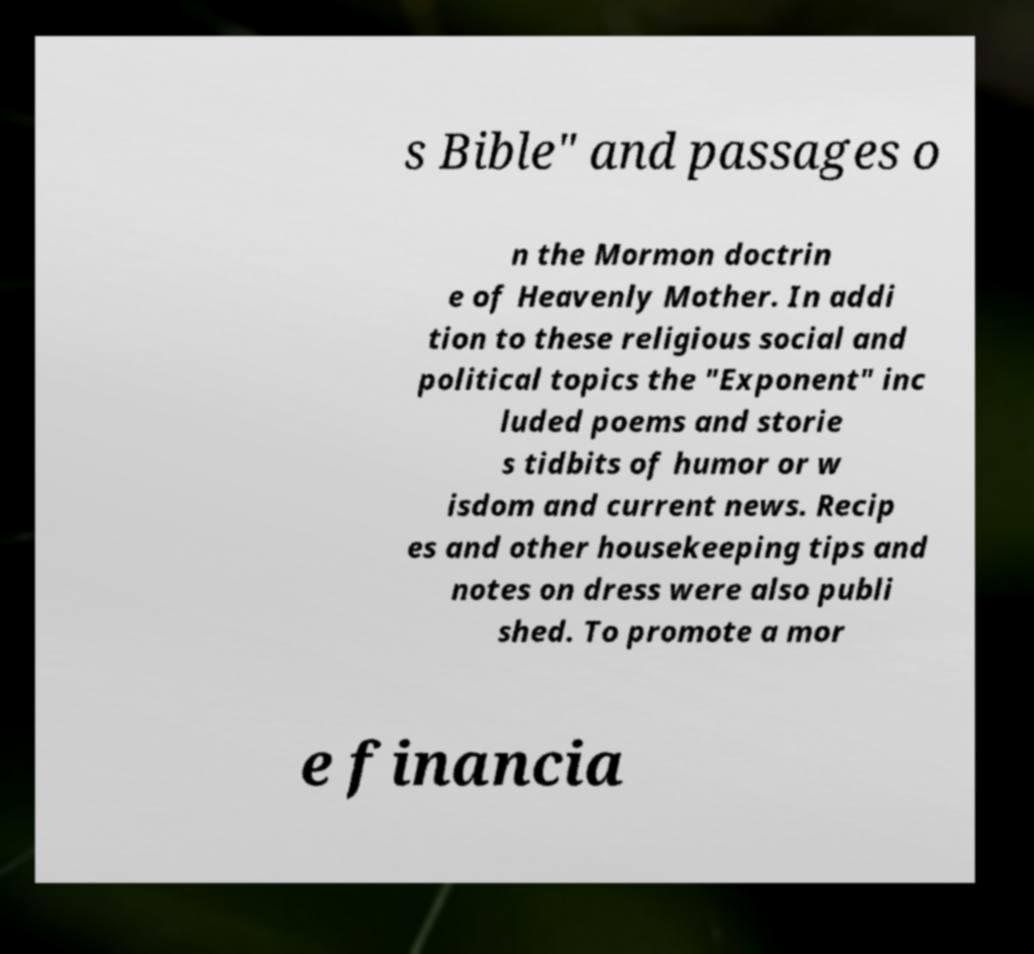Could you extract and type out the text from this image? s Bible" and passages o n the Mormon doctrin e of Heavenly Mother. In addi tion to these religious social and political topics the "Exponent" inc luded poems and storie s tidbits of humor or w isdom and current news. Recip es and other housekeeping tips and notes on dress were also publi shed. To promote a mor e financia 